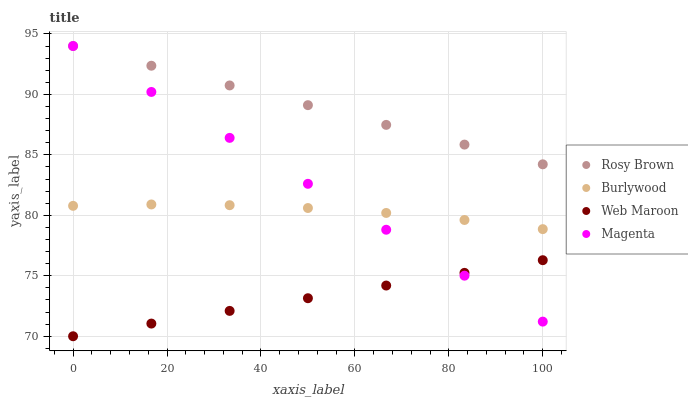Does Web Maroon have the minimum area under the curve?
Answer yes or no. Yes. Does Rosy Brown have the maximum area under the curve?
Answer yes or no. Yes. Does Magenta have the minimum area under the curve?
Answer yes or no. No. Does Magenta have the maximum area under the curve?
Answer yes or no. No. Is Web Maroon the smoothest?
Answer yes or no. Yes. Is Burlywood the roughest?
Answer yes or no. Yes. Is Magenta the smoothest?
Answer yes or no. No. Is Magenta the roughest?
Answer yes or no. No. Does Web Maroon have the lowest value?
Answer yes or no. Yes. Does Magenta have the lowest value?
Answer yes or no. No. Does Rosy Brown have the highest value?
Answer yes or no. Yes. Does Web Maroon have the highest value?
Answer yes or no. No. Is Web Maroon less than Rosy Brown?
Answer yes or no. Yes. Is Rosy Brown greater than Web Maroon?
Answer yes or no. Yes. Does Web Maroon intersect Magenta?
Answer yes or no. Yes. Is Web Maroon less than Magenta?
Answer yes or no. No. Is Web Maroon greater than Magenta?
Answer yes or no. No. Does Web Maroon intersect Rosy Brown?
Answer yes or no. No. 